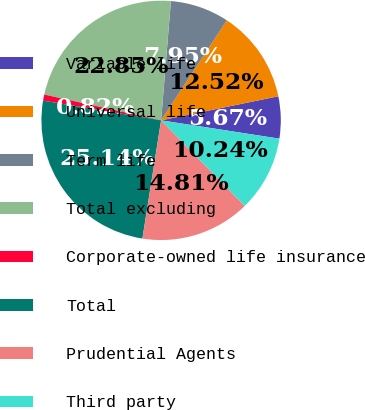<chart> <loc_0><loc_0><loc_500><loc_500><pie_chart><fcel>Variable life<fcel>Universal life<fcel>Term life<fcel>Total excluding<fcel>Corporate-owned life insurance<fcel>Total<fcel>Prudential Agents<fcel>Third party<nl><fcel>5.67%<fcel>12.52%<fcel>7.95%<fcel>22.85%<fcel>0.82%<fcel>25.14%<fcel>14.81%<fcel>10.24%<nl></chart> 